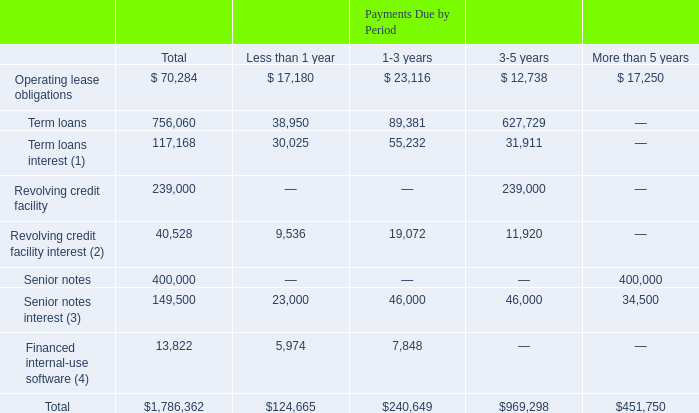Contractual Obligations and Commercial Commitments
We lease office space and equipment under operating leases that run through October 2028. Additionally, we have entered into a Credit Agreement that matures in April 2024 and have issued Senior Notes that mature in August 2026.
Contractual obligations as of December 31, 2019, are as follows (in thousands):
(1) Based on the Term Loans debt outstanding and interest rate in effect at December 31, 2019, of 4.05%.
(2) Based on Revolving Credit Facility debt outstanding and interest rate in effect at December 31, 2019, of 3.99%.
(3) Based on 2026 Notes issued of $400.0 million with an annual interest rate of 5.750%.
(4) During the year ended December 31, 2019, we financed certain multi-year license agreements for internal-use software for $10.4 million with annual payments through April 1, 2022. As of December 31, 2019, $13.8 million is outstanding under these and other agreements previously entered into, of which $6.0 million and $7.8 million is included in other current liabilities and other noncurrent liabilities, respectively, in our Consolidated Balance Sheet in Part IV, Item 15 of this Form 10-K as of December 31, 2019.
We are unable to reasonably estimate the ultimate amount or timing of settlement of our reserves for income taxes under ASC 740, Income Taxes. The liability for unrecognized tax benefits at December 31, 2019, is $29.0 million.
What were the term loans based on? The term loans debt outstanding and interest rate in effect at december 31, 2019, of 4.05%. What was the total term loans?
Answer scale should be: thousand. 756,060. What was the total term loans interest?
Answer scale should be: thousand. 117,168. What percentage of the total consists of payments due less than 1 year?
Answer scale should be: percent. $124,665/$1,786,362
Answer: 6.98. What percentage of the total consists of payments due in 1-3 years?
Answer scale should be: percent. $240,649/$1,786,362
Answer: 13.47. What percentage of the total contractual obligations consists of term loans?
Answer scale should be: percent. 756,060/$1,786,362
Answer: 42.32. 